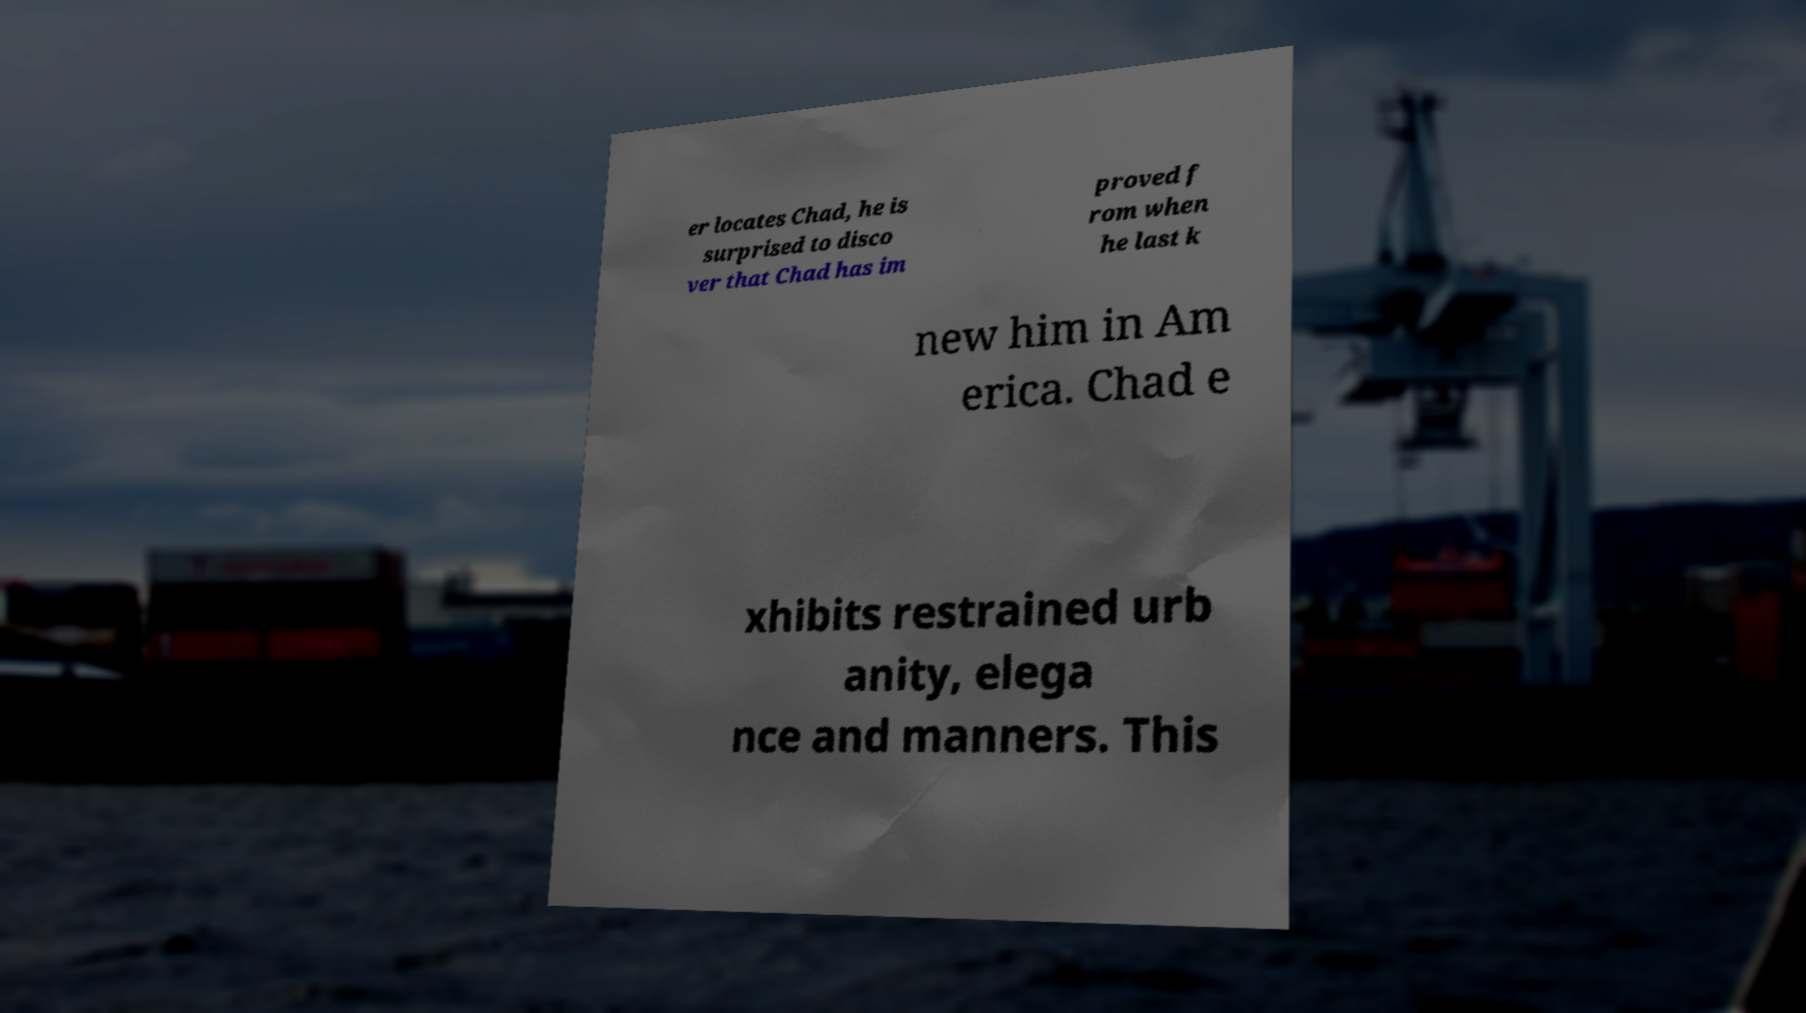I need the written content from this picture converted into text. Can you do that? er locates Chad, he is surprised to disco ver that Chad has im proved f rom when he last k new him in Am erica. Chad e xhibits restrained urb anity, elega nce and manners. This 